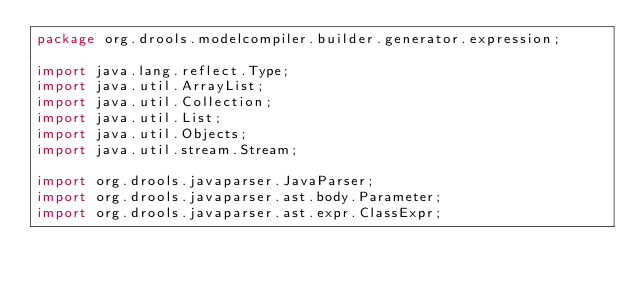<code> <loc_0><loc_0><loc_500><loc_500><_Java_>package org.drools.modelcompiler.builder.generator.expression;

import java.lang.reflect.Type;
import java.util.ArrayList;
import java.util.Collection;
import java.util.List;
import java.util.Objects;
import java.util.stream.Stream;

import org.drools.javaparser.JavaParser;
import org.drools.javaparser.ast.body.Parameter;
import org.drools.javaparser.ast.expr.ClassExpr;</code> 